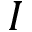<formula> <loc_0><loc_0><loc_500><loc_500>I</formula> 